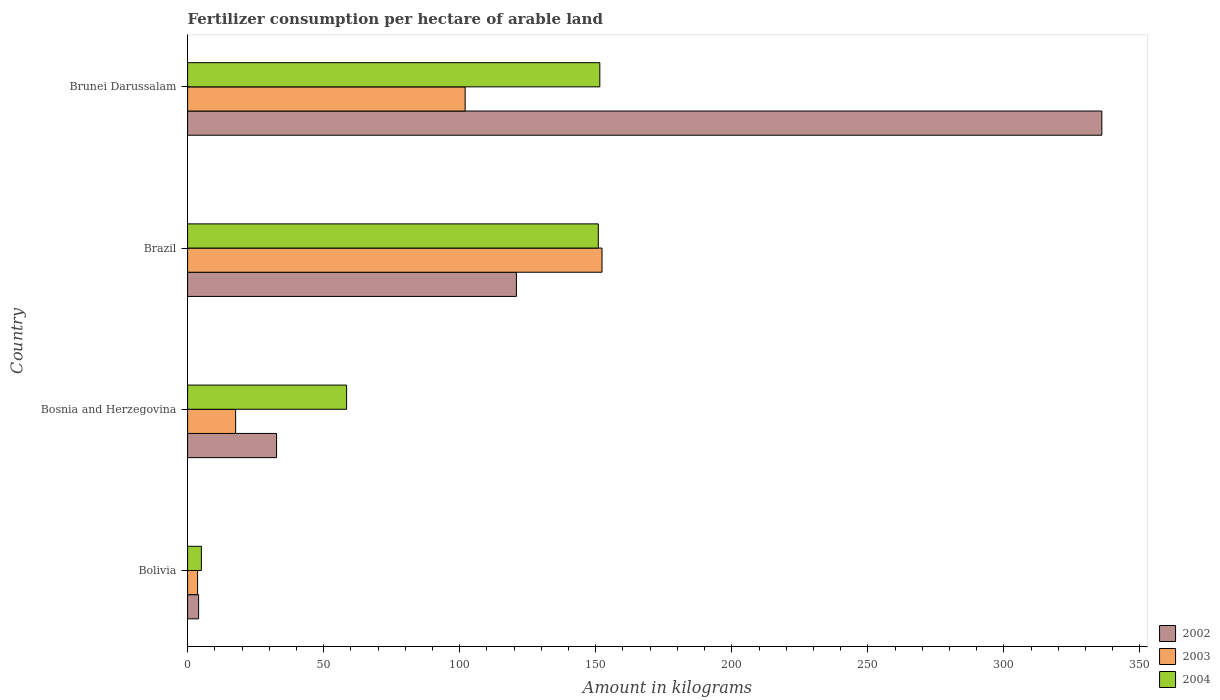How many groups of bars are there?
Offer a terse response. 4. Are the number of bars per tick equal to the number of legend labels?
Your response must be concise. Yes. Are the number of bars on each tick of the Y-axis equal?
Your response must be concise. Yes. How many bars are there on the 3rd tick from the top?
Your answer should be compact. 3. How many bars are there on the 3rd tick from the bottom?
Keep it short and to the point. 3. What is the amount of fertilizer consumption in 2004 in Brazil?
Ensure brevity in your answer.  150.95. Across all countries, what is the maximum amount of fertilizer consumption in 2002?
Make the answer very short. 336. Across all countries, what is the minimum amount of fertilizer consumption in 2002?
Ensure brevity in your answer.  4.04. In which country was the amount of fertilizer consumption in 2004 maximum?
Make the answer very short. Brunei Darussalam. In which country was the amount of fertilizer consumption in 2004 minimum?
Provide a short and direct response. Bolivia. What is the total amount of fertilizer consumption in 2002 in the graph?
Make the answer very short. 493.58. What is the difference between the amount of fertilizer consumption in 2004 in Bosnia and Herzegovina and that in Brunei Darussalam?
Provide a succinct answer. -93.06. What is the difference between the amount of fertilizer consumption in 2003 in Bolivia and the amount of fertilizer consumption in 2002 in Brunei Darussalam?
Offer a terse response. -332.32. What is the average amount of fertilizer consumption in 2004 per country?
Your response must be concise. 91.49. What is the difference between the amount of fertilizer consumption in 2002 and amount of fertilizer consumption in 2003 in Brunei Darussalam?
Keep it short and to the point. 234. What is the ratio of the amount of fertilizer consumption in 2002 in Bolivia to that in Brunei Darussalam?
Give a very brief answer. 0.01. Is the amount of fertilizer consumption in 2003 in Bolivia less than that in Brunei Darussalam?
Give a very brief answer. Yes. What is the difference between the highest and the second highest amount of fertilizer consumption in 2004?
Provide a short and direct response. 0.55. What is the difference between the highest and the lowest amount of fertilizer consumption in 2002?
Offer a terse response. 331.96. What does the 1st bar from the bottom in Bosnia and Herzegovina represents?
Give a very brief answer. 2002. How many bars are there?
Offer a very short reply. 12. Are all the bars in the graph horizontal?
Offer a very short reply. Yes. What is the difference between two consecutive major ticks on the X-axis?
Your response must be concise. 50. Are the values on the major ticks of X-axis written in scientific E-notation?
Give a very brief answer. No. How many legend labels are there?
Your response must be concise. 3. What is the title of the graph?
Give a very brief answer. Fertilizer consumption per hectare of arable land. What is the label or title of the X-axis?
Make the answer very short. Amount in kilograms. What is the Amount in kilograms of 2002 in Bolivia?
Make the answer very short. 4.04. What is the Amount in kilograms in 2003 in Bolivia?
Offer a terse response. 3.68. What is the Amount in kilograms of 2004 in Bolivia?
Your response must be concise. 5.06. What is the Amount in kilograms in 2002 in Bosnia and Herzegovina?
Your answer should be compact. 32.7. What is the Amount in kilograms in 2003 in Bosnia and Herzegovina?
Provide a short and direct response. 17.66. What is the Amount in kilograms of 2004 in Bosnia and Herzegovina?
Your answer should be very brief. 58.44. What is the Amount in kilograms in 2002 in Brazil?
Provide a short and direct response. 120.84. What is the Amount in kilograms of 2003 in Brazil?
Provide a succinct answer. 152.31. What is the Amount in kilograms in 2004 in Brazil?
Make the answer very short. 150.95. What is the Amount in kilograms of 2002 in Brunei Darussalam?
Ensure brevity in your answer.  336. What is the Amount in kilograms in 2003 in Brunei Darussalam?
Your answer should be very brief. 102. What is the Amount in kilograms in 2004 in Brunei Darussalam?
Make the answer very short. 151.5. Across all countries, what is the maximum Amount in kilograms in 2002?
Provide a succinct answer. 336. Across all countries, what is the maximum Amount in kilograms of 2003?
Give a very brief answer. 152.31. Across all countries, what is the maximum Amount in kilograms in 2004?
Provide a short and direct response. 151.5. Across all countries, what is the minimum Amount in kilograms of 2002?
Ensure brevity in your answer.  4.04. Across all countries, what is the minimum Amount in kilograms of 2003?
Your answer should be compact. 3.68. Across all countries, what is the minimum Amount in kilograms in 2004?
Your answer should be compact. 5.06. What is the total Amount in kilograms in 2002 in the graph?
Your answer should be compact. 493.58. What is the total Amount in kilograms of 2003 in the graph?
Your response must be concise. 275.64. What is the total Amount in kilograms in 2004 in the graph?
Give a very brief answer. 365.95. What is the difference between the Amount in kilograms of 2002 in Bolivia and that in Bosnia and Herzegovina?
Keep it short and to the point. -28.66. What is the difference between the Amount in kilograms of 2003 in Bolivia and that in Bosnia and Herzegovina?
Your answer should be compact. -13.98. What is the difference between the Amount in kilograms of 2004 in Bolivia and that in Bosnia and Herzegovina?
Offer a terse response. -53.38. What is the difference between the Amount in kilograms in 2002 in Bolivia and that in Brazil?
Give a very brief answer. -116.8. What is the difference between the Amount in kilograms of 2003 in Bolivia and that in Brazil?
Make the answer very short. -148.63. What is the difference between the Amount in kilograms in 2004 in Bolivia and that in Brazil?
Your response must be concise. -145.88. What is the difference between the Amount in kilograms of 2002 in Bolivia and that in Brunei Darussalam?
Keep it short and to the point. -331.96. What is the difference between the Amount in kilograms of 2003 in Bolivia and that in Brunei Darussalam?
Ensure brevity in your answer.  -98.32. What is the difference between the Amount in kilograms of 2004 in Bolivia and that in Brunei Darussalam?
Make the answer very short. -146.44. What is the difference between the Amount in kilograms in 2002 in Bosnia and Herzegovina and that in Brazil?
Offer a very short reply. -88.14. What is the difference between the Amount in kilograms of 2003 in Bosnia and Herzegovina and that in Brazil?
Your answer should be compact. -134.65. What is the difference between the Amount in kilograms in 2004 in Bosnia and Herzegovina and that in Brazil?
Provide a succinct answer. -92.5. What is the difference between the Amount in kilograms in 2002 in Bosnia and Herzegovina and that in Brunei Darussalam?
Your answer should be very brief. -303.3. What is the difference between the Amount in kilograms in 2003 in Bosnia and Herzegovina and that in Brunei Darussalam?
Give a very brief answer. -84.34. What is the difference between the Amount in kilograms in 2004 in Bosnia and Herzegovina and that in Brunei Darussalam?
Give a very brief answer. -93.06. What is the difference between the Amount in kilograms of 2002 in Brazil and that in Brunei Darussalam?
Provide a short and direct response. -215.16. What is the difference between the Amount in kilograms of 2003 in Brazil and that in Brunei Darussalam?
Offer a terse response. 50.31. What is the difference between the Amount in kilograms in 2004 in Brazil and that in Brunei Darussalam?
Provide a short and direct response. -0.55. What is the difference between the Amount in kilograms of 2002 in Bolivia and the Amount in kilograms of 2003 in Bosnia and Herzegovina?
Offer a terse response. -13.61. What is the difference between the Amount in kilograms of 2002 in Bolivia and the Amount in kilograms of 2004 in Bosnia and Herzegovina?
Make the answer very short. -54.4. What is the difference between the Amount in kilograms of 2003 in Bolivia and the Amount in kilograms of 2004 in Bosnia and Herzegovina?
Provide a short and direct response. -54.77. What is the difference between the Amount in kilograms of 2002 in Bolivia and the Amount in kilograms of 2003 in Brazil?
Make the answer very short. -148.26. What is the difference between the Amount in kilograms in 2002 in Bolivia and the Amount in kilograms in 2004 in Brazil?
Provide a succinct answer. -146.9. What is the difference between the Amount in kilograms of 2003 in Bolivia and the Amount in kilograms of 2004 in Brazil?
Provide a short and direct response. -147.27. What is the difference between the Amount in kilograms in 2002 in Bolivia and the Amount in kilograms in 2003 in Brunei Darussalam?
Make the answer very short. -97.96. What is the difference between the Amount in kilograms of 2002 in Bolivia and the Amount in kilograms of 2004 in Brunei Darussalam?
Give a very brief answer. -147.46. What is the difference between the Amount in kilograms of 2003 in Bolivia and the Amount in kilograms of 2004 in Brunei Darussalam?
Provide a succinct answer. -147.82. What is the difference between the Amount in kilograms in 2002 in Bosnia and Herzegovina and the Amount in kilograms in 2003 in Brazil?
Keep it short and to the point. -119.61. What is the difference between the Amount in kilograms of 2002 in Bosnia and Herzegovina and the Amount in kilograms of 2004 in Brazil?
Offer a terse response. -118.25. What is the difference between the Amount in kilograms in 2003 in Bosnia and Herzegovina and the Amount in kilograms in 2004 in Brazil?
Your response must be concise. -133.29. What is the difference between the Amount in kilograms in 2002 in Bosnia and Herzegovina and the Amount in kilograms in 2003 in Brunei Darussalam?
Your response must be concise. -69.3. What is the difference between the Amount in kilograms in 2002 in Bosnia and Herzegovina and the Amount in kilograms in 2004 in Brunei Darussalam?
Make the answer very short. -118.8. What is the difference between the Amount in kilograms of 2003 in Bosnia and Herzegovina and the Amount in kilograms of 2004 in Brunei Darussalam?
Make the answer very short. -133.84. What is the difference between the Amount in kilograms of 2002 in Brazil and the Amount in kilograms of 2003 in Brunei Darussalam?
Your answer should be very brief. 18.84. What is the difference between the Amount in kilograms of 2002 in Brazil and the Amount in kilograms of 2004 in Brunei Darussalam?
Provide a succinct answer. -30.66. What is the difference between the Amount in kilograms of 2003 in Brazil and the Amount in kilograms of 2004 in Brunei Darussalam?
Offer a very short reply. 0.81. What is the average Amount in kilograms in 2002 per country?
Keep it short and to the point. 123.4. What is the average Amount in kilograms in 2003 per country?
Keep it short and to the point. 68.91. What is the average Amount in kilograms of 2004 per country?
Offer a very short reply. 91.49. What is the difference between the Amount in kilograms in 2002 and Amount in kilograms in 2003 in Bolivia?
Your response must be concise. 0.37. What is the difference between the Amount in kilograms in 2002 and Amount in kilograms in 2004 in Bolivia?
Provide a succinct answer. -1.02. What is the difference between the Amount in kilograms of 2003 and Amount in kilograms of 2004 in Bolivia?
Make the answer very short. -1.39. What is the difference between the Amount in kilograms in 2002 and Amount in kilograms in 2003 in Bosnia and Herzegovina?
Give a very brief answer. 15.04. What is the difference between the Amount in kilograms of 2002 and Amount in kilograms of 2004 in Bosnia and Herzegovina?
Provide a succinct answer. -25.74. What is the difference between the Amount in kilograms in 2003 and Amount in kilograms in 2004 in Bosnia and Herzegovina?
Offer a very short reply. -40.79. What is the difference between the Amount in kilograms in 2002 and Amount in kilograms in 2003 in Brazil?
Your answer should be compact. -31.46. What is the difference between the Amount in kilograms of 2002 and Amount in kilograms of 2004 in Brazil?
Make the answer very short. -30.11. What is the difference between the Amount in kilograms of 2003 and Amount in kilograms of 2004 in Brazil?
Your answer should be compact. 1.36. What is the difference between the Amount in kilograms of 2002 and Amount in kilograms of 2003 in Brunei Darussalam?
Give a very brief answer. 234. What is the difference between the Amount in kilograms in 2002 and Amount in kilograms in 2004 in Brunei Darussalam?
Give a very brief answer. 184.5. What is the difference between the Amount in kilograms of 2003 and Amount in kilograms of 2004 in Brunei Darussalam?
Ensure brevity in your answer.  -49.5. What is the ratio of the Amount in kilograms of 2002 in Bolivia to that in Bosnia and Herzegovina?
Provide a short and direct response. 0.12. What is the ratio of the Amount in kilograms of 2003 in Bolivia to that in Bosnia and Herzegovina?
Make the answer very short. 0.21. What is the ratio of the Amount in kilograms in 2004 in Bolivia to that in Bosnia and Herzegovina?
Your answer should be very brief. 0.09. What is the ratio of the Amount in kilograms of 2002 in Bolivia to that in Brazil?
Provide a succinct answer. 0.03. What is the ratio of the Amount in kilograms in 2003 in Bolivia to that in Brazil?
Keep it short and to the point. 0.02. What is the ratio of the Amount in kilograms in 2004 in Bolivia to that in Brazil?
Your answer should be very brief. 0.03. What is the ratio of the Amount in kilograms of 2002 in Bolivia to that in Brunei Darussalam?
Make the answer very short. 0.01. What is the ratio of the Amount in kilograms of 2003 in Bolivia to that in Brunei Darussalam?
Your answer should be compact. 0.04. What is the ratio of the Amount in kilograms in 2004 in Bolivia to that in Brunei Darussalam?
Provide a short and direct response. 0.03. What is the ratio of the Amount in kilograms of 2002 in Bosnia and Herzegovina to that in Brazil?
Give a very brief answer. 0.27. What is the ratio of the Amount in kilograms in 2003 in Bosnia and Herzegovina to that in Brazil?
Offer a very short reply. 0.12. What is the ratio of the Amount in kilograms in 2004 in Bosnia and Herzegovina to that in Brazil?
Your answer should be compact. 0.39. What is the ratio of the Amount in kilograms in 2002 in Bosnia and Herzegovina to that in Brunei Darussalam?
Offer a very short reply. 0.1. What is the ratio of the Amount in kilograms in 2003 in Bosnia and Herzegovina to that in Brunei Darussalam?
Your response must be concise. 0.17. What is the ratio of the Amount in kilograms in 2004 in Bosnia and Herzegovina to that in Brunei Darussalam?
Your answer should be compact. 0.39. What is the ratio of the Amount in kilograms of 2002 in Brazil to that in Brunei Darussalam?
Provide a succinct answer. 0.36. What is the ratio of the Amount in kilograms in 2003 in Brazil to that in Brunei Darussalam?
Give a very brief answer. 1.49. What is the ratio of the Amount in kilograms in 2004 in Brazil to that in Brunei Darussalam?
Ensure brevity in your answer.  1. What is the difference between the highest and the second highest Amount in kilograms of 2002?
Ensure brevity in your answer.  215.16. What is the difference between the highest and the second highest Amount in kilograms of 2003?
Ensure brevity in your answer.  50.31. What is the difference between the highest and the second highest Amount in kilograms of 2004?
Keep it short and to the point. 0.55. What is the difference between the highest and the lowest Amount in kilograms of 2002?
Give a very brief answer. 331.96. What is the difference between the highest and the lowest Amount in kilograms in 2003?
Your answer should be compact. 148.63. What is the difference between the highest and the lowest Amount in kilograms in 2004?
Your answer should be compact. 146.44. 